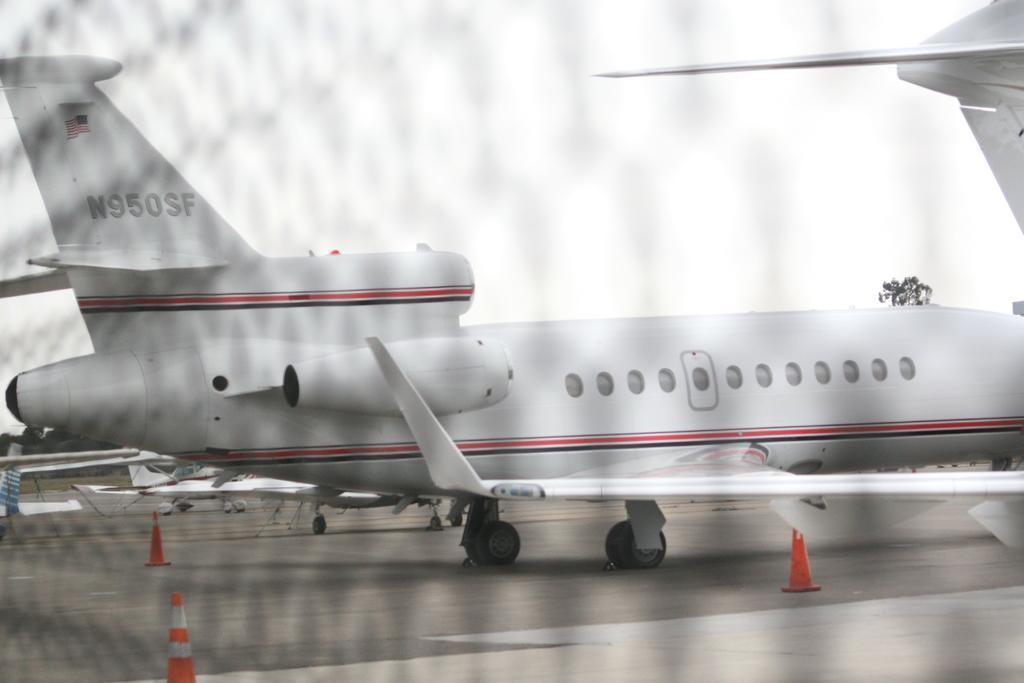Can you describe this image briefly? In this image I can see few airplanes on the ground. At the top of the image I can see the sky. In the background there are some trees. 